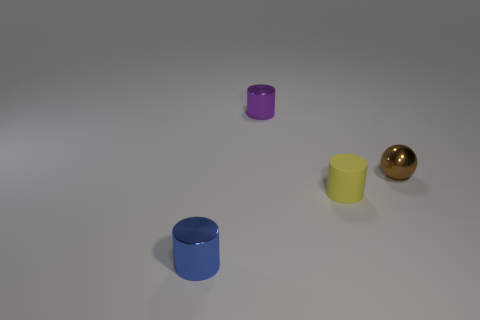There is a shiny object that is to the right of the small purple cylinder; is its shape the same as the thing that is in front of the rubber cylinder?
Your response must be concise. No. Is there any other thing that has the same material as the tiny blue object?
Your answer should be compact. Yes. What is the tiny sphere made of?
Keep it short and to the point. Metal. What material is the tiny cylinder behind the small yellow object?
Give a very brief answer. Metal. Is there any other thing that is the same color as the rubber object?
Offer a very short reply. No. What size is the purple cylinder that is the same material as the tiny brown object?
Offer a very short reply. Small. What number of tiny things are green shiny cylinders or blue things?
Provide a short and direct response. 1. There is a metallic cylinder to the right of the object on the left side of the cylinder behind the tiny rubber cylinder; how big is it?
Offer a terse response. Small. How many purple rubber objects are the same size as the blue metallic object?
Offer a very short reply. 0. How many things are small purple shiny cylinders or shiny cylinders that are behind the tiny metal ball?
Give a very brief answer. 1. 